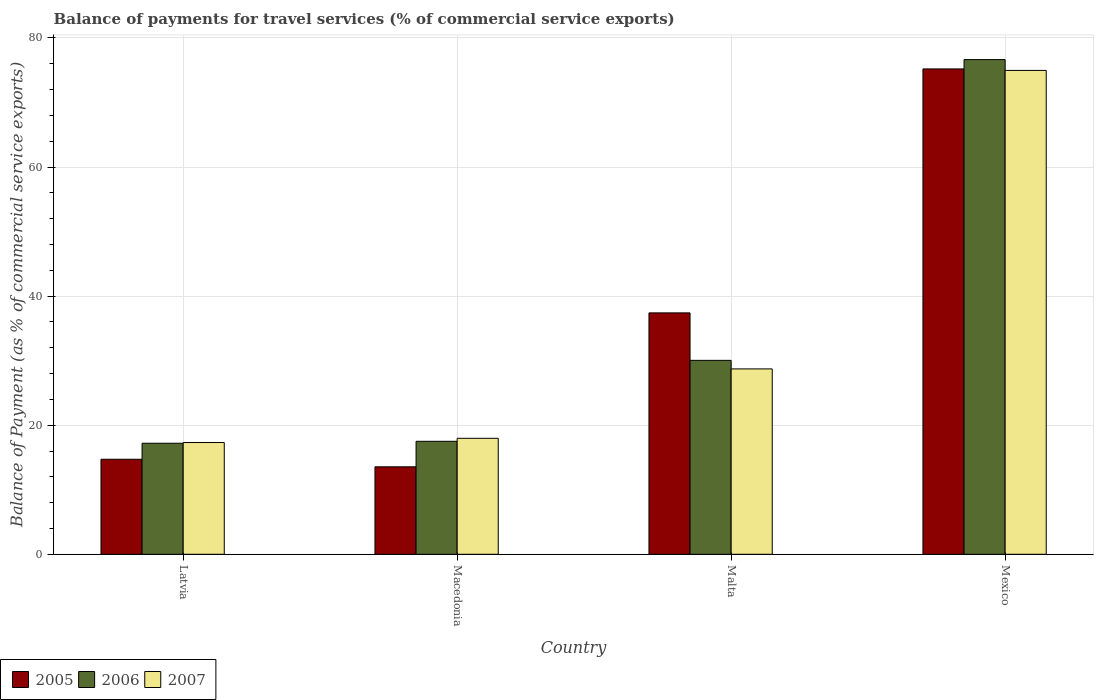Are the number of bars on each tick of the X-axis equal?
Make the answer very short. Yes. What is the label of the 1st group of bars from the left?
Your answer should be compact. Latvia. What is the balance of payments for travel services in 2006 in Malta?
Provide a short and direct response. 30.05. Across all countries, what is the maximum balance of payments for travel services in 2006?
Provide a succinct answer. 76.64. Across all countries, what is the minimum balance of payments for travel services in 2007?
Your answer should be compact. 17.32. In which country was the balance of payments for travel services in 2006 maximum?
Offer a very short reply. Mexico. In which country was the balance of payments for travel services in 2006 minimum?
Your answer should be compact. Latvia. What is the total balance of payments for travel services in 2005 in the graph?
Make the answer very short. 140.87. What is the difference between the balance of payments for travel services in 2005 in Latvia and that in Macedonia?
Your answer should be compact. 1.17. What is the difference between the balance of payments for travel services in 2007 in Malta and the balance of payments for travel services in 2005 in Macedonia?
Give a very brief answer. 15.17. What is the average balance of payments for travel services in 2007 per country?
Ensure brevity in your answer.  34.74. What is the difference between the balance of payments for travel services of/in 2007 and balance of payments for travel services of/in 2006 in Malta?
Offer a very short reply. -1.32. In how many countries, is the balance of payments for travel services in 2007 greater than 24 %?
Ensure brevity in your answer.  2. What is the ratio of the balance of payments for travel services in 2005 in Latvia to that in Mexico?
Offer a very short reply. 0.2. Is the difference between the balance of payments for travel services in 2007 in Macedonia and Mexico greater than the difference between the balance of payments for travel services in 2006 in Macedonia and Mexico?
Provide a short and direct response. Yes. What is the difference between the highest and the second highest balance of payments for travel services in 2006?
Give a very brief answer. -59.14. What is the difference between the highest and the lowest balance of payments for travel services in 2005?
Make the answer very short. 61.64. In how many countries, is the balance of payments for travel services in 2005 greater than the average balance of payments for travel services in 2005 taken over all countries?
Your response must be concise. 2. Is the sum of the balance of payments for travel services in 2007 in Malta and Mexico greater than the maximum balance of payments for travel services in 2006 across all countries?
Give a very brief answer. Yes. What does the 2nd bar from the left in Malta represents?
Your answer should be very brief. 2006. Is it the case that in every country, the sum of the balance of payments for travel services in 2006 and balance of payments for travel services in 2007 is greater than the balance of payments for travel services in 2005?
Your answer should be very brief. Yes. How many bars are there?
Your answer should be compact. 12. What is the difference between two consecutive major ticks on the Y-axis?
Your answer should be very brief. 20. Are the values on the major ticks of Y-axis written in scientific E-notation?
Provide a short and direct response. No. Does the graph contain any zero values?
Provide a succinct answer. No. Does the graph contain grids?
Give a very brief answer. Yes. Where does the legend appear in the graph?
Keep it short and to the point. Bottom left. What is the title of the graph?
Your answer should be compact. Balance of payments for travel services (% of commercial service exports). Does "1962" appear as one of the legend labels in the graph?
Make the answer very short. No. What is the label or title of the Y-axis?
Provide a short and direct response. Balance of Payment (as % of commercial service exports). What is the Balance of Payment (as % of commercial service exports) in 2005 in Latvia?
Your response must be concise. 14.72. What is the Balance of Payment (as % of commercial service exports) in 2006 in Latvia?
Your answer should be very brief. 17.2. What is the Balance of Payment (as % of commercial service exports) of 2007 in Latvia?
Keep it short and to the point. 17.32. What is the Balance of Payment (as % of commercial service exports) of 2005 in Macedonia?
Your answer should be very brief. 13.55. What is the Balance of Payment (as % of commercial service exports) in 2006 in Macedonia?
Ensure brevity in your answer.  17.5. What is the Balance of Payment (as % of commercial service exports) of 2007 in Macedonia?
Your answer should be compact. 17.97. What is the Balance of Payment (as % of commercial service exports) of 2005 in Malta?
Provide a short and direct response. 37.4. What is the Balance of Payment (as % of commercial service exports) of 2006 in Malta?
Provide a succinct answer. 30.05. What is the Balance of Payment (as % of commercial service exports) of 2007 in Malta?
Ensure brevity in your answer.  28.72. What is the Balance of Payment (as % of commercial service exports) in 2005 in Mexico?
Ensure brevity in your answer.  75.19. What is the Balance of Payment (as % of commercial service exports) of 2006 in Mexico?
Your answer should be compact. 76.64. What is the Balance of Payment (as % of commercial service exports) in 2007 in Mexico?
Make the answer very short. 74.97. Across all countries, what is the maximum Balance of Payment (as % of commercial service exports) of 2005?
Make the answer very short. 75.19. Across all countries, what is the maximum Balance of Payment (as % of commercial service exports) of 2006?
Your answer should be very brief. 76.64. Across all countries, what is the maximum Balance of Payment (as % of commercial service exports) in 2007?
Keep it short and to the point. 74.97. Across all countries, what is the minimum Balance of Payment (as % of commercial service exports) of 2005?
Your response must be concise. 13.55. Across all countries, what is the minimum Balance of Payment (as % of commercial service exports) in 2006?
Keep it short and to the point. 17.2. Across all countries, what is the minimum Balance of Payment (as % of commercial service exports) in 2007?
Provide a short and direct response. 17.32. What is the total Balance of Payment (as % of commercial service exports) in 2005 in the graph?
Keep it short and to the point. 140.87. What is the total Balance of Payment (as % of commercial service exports) of 2006 in the graph?
Ensure brevity in your answer.  141.39. What is the total Balance of Payment (as % of commercial service exports) in 2007 in the graph?
Offer a very short reply. 138.98. What is the difference between the Balance of Payment (as % of commercial service exports) in 2005 in Latvia and that in Macedonia?
Make the answer very short. 1.17. What is the difference between the Balance of Payment (as % of commercial service exports) in 2006 in Latvia and that in Macedonia?
Keep it short and to the point. -0.3. What is the difference between the Balance of Payment (as % of commercial service exports) in 2007 in Latvia and that in Macedonia?
Provide a succinct answer. -0.65. What is the difference between the Balance of Payment (as % of commercial service exports) in 2005 in Latvia and that in Malta?
Provide a succinct answer. -22.68. What is the difference between the Balance of Payment (as % of commercial service exports) in 2006 in Latvia and that in Malta?
Your answer should be compact. -12.84. What is the difference between the Balance of Payment (as % of commercial service exports) of 2007 in Latvia and that in Malta?
Provide a short and direct response. -11.4. What is the difference between the Balance of Payment (as % of commercial service exports) in 2005 in Latvia and that in Mexico?
Make the answer very short. -60.47. What is the difference between the Balance of Payment (as % of commercial service exports) in 2006 in Latvia and that in Mexico?
Your answer should be very brief. -59.44. What is the difference between the Balance of Payment (as % of commercial service exports) of 2007 in Latvia and that in Mexico?
Your answer should be very brief. -57.65. What is the difference between the Balance of Payment (as % of commercial service exports) in 2005 in Macedonia and that in Malta?
Ensure brevity in your answer.  -23.85. What is the difference between the Balance of Payment (as % of commercial service exports) of 2006 in Macedonia and that in Malta?
Provide a succinct answer. -12.54. What is the difference between the Balance of Payment (as % of commercial service exports) in 2007 in Macedonia and that in Malta?
Your answer should be very brief. -10.75. What is the difference between the Balance of Payment (as % of commercial service exports) of 2005 in Macedonia and that in Mexico?
Your answer should be very brief. -61.64. What is the difference between the Balance of Payment (as % of commercial service exports) in 2006 in Macedonia and that in Mexico?
Provide a succinct answer. -59.14. What is the difference between the Balance of Payment (as % of commercial service exports) of 2007 in Macedonia and that in Mexico?
Your response must be concise. -57. What is the difference between the Balance of Payment (as % of commercial service exports) of 2005 in Malta and that in Mexico?
Your response must be concise. -37.79. What is the difference between the Balance of Payment (as % of commercial service exports) of 2006 in Malta and that in Mexico?
Provide a succinct answer. -46.59. What is the difference between the Balance of Payment (as % of commercial service exports) in 2007 in Malta and that in Mexico?
Offer a terse response. -46.24. What is the difference between the Balance of Payment (as % of commercial service exports) of 2005 in Latvia and the Balance of Payment (as % of commercial service exports) of 2006 in Macedonia?
Ensure brevity in your answer.  -2.78. What is the difference between the Balance of Payment (as % of commercial service exports) in 2005 in Latvia and the Balance of Payment (as % of commercial service exports) in 2007 in Macedonia?
Keep it short and to the point. -3.25. What is the difference between the Balance of Payment (as % of commercial service exports) of 2006 in Latvia and the Balance of Payment (as % of commercial service exports) of 2007 in Macedonia?
Your answer should be compact. -0.77. What is the difference between the Balance of Payment (as % of commercial service exports) of 2005 in Latvia and the Balance of Payment (as % of commercial service exports) of 2006 in Malta?
Your answer should be very brief. -15.32. What is the difference between the Balance of Payment (as % of commercial service exports) in 2005 in Latvia and the Balance of Payment (as % of commercial service exports) in 2007 in Malta?
Provide a succinct answer. -14. What is the difference between the Balance of Payment (as % of commercial service exports) of 2006 in Latvia and the Balance of Payment (as % of commercial service exports) of 2007 in Malta?
Provide a short and direct response. -11.52. What is the difference between the Balance of Payment (as % of commercial service exports) in 2005 in Latvia and the Balance of Payment (as % of commercial service exports) in 2006 in Mexico?
Offer a very short reply. -61.92. What is the difference between the Balance of Payment (as % of commercial service exports) in 2005 in Latvia and the Balance of Payment (as % of commercial service exports) in 2007 in Mexico?
Keep it short and to the point. -60.24. What is the difference between the Balance of Payment (as % of commercial service exports) of 2006 in Latvia and the Balance of Payment (as % of commercial service exports) of 2007 in Mexico?
Provide a short and direct response. -57.76. What is the difference between the Balance of Payment (as % of commercial service exports) in 2005 in Macedonia and the Balance of Payment (as % of commercial service exports) in 2006 in Malta?
Give a very brief answer. -16.49. What is the difference between the Balance of Payment (as % of commercial service exports) of 2005 in Macedonia and the Balance of Payment (as % of commercial service exports) of 2007 in Malta?
Your answer should be compact. -15.17. What is the difference between the Balance of Payment (as % of commercial service exports) of 2006 in Macedonia and the Balance of Payment (as % of commercial service exports) of 2007 in Malta?
Make the answer very short. -11.22. What is the difference between the Balance of Payment (as % of commercial service exports) in 2005 in Macedonia and the Balance of Payment (as % of commercial service exports) in 2006 in Mexico?
Ensure brevity in your answer.  -63.09. What is the difference between the Balance of Payment (as % of commercial service exports) in 2005 in Macedonia and the Balance of Payment (as % of commercial service exports) in 2007 in Mexico?
Your answer should be compact. -61.41. What is the difference between the Balance of Payment (as % of commercial service exports) in 2006 in Macedonia and the Balance of Payment (as % of commercial service exports) in 2007 in Mexico?
Keep it short and to the point. -57.46. What is the difference between the Balance of Payment (as % of commercial service exports) in 2005 in Malta and the Balance of Payment (as % of commercial service exports) in 2006 in Mexico?
Give a very brief answer. -39.24. What is the difference between the Balance of Payment (as % of commercial service exports) in 2005 in Malta and the Balance of Payment (as % of commercial service exports) in 2007 in Mexico?
Offer a very short reply. -37.57. What is the difference between the Balance of Payment (as % of commercial service exports) in 2006 in Malta and the Balance of Payment (as % of commercial service exports) in 2007 in Mexico?
Your answer should be very brief. -44.92. What is the average Balance of Payment (as % of commercial service exports) of 2005 per country?
Keep it short and to the point. 35.22. What is the average Balance of Payment (as % of commercial service exports) in 2006 per country?
Offer a terse response. 35.35. What is the average Balance of Payment (as % of commercial service exports) of 2007 per country?
Offer a very short reply. 34.74. What is the difference between the Balance of Payment (as % of commercial service exports) of 2005 and Balance of Payment (as % of commercial service exports) of 2006 in Latvia?
Ensure brevity in your answer.  -2.48. What is the difference between the Balance of Payment (as % of commercial service exports) of 2005 and Balance of Payment (as % of commercial service exports) of 2007 in Latvia?
Give a very brief answer. -2.59. What is the difference between the Balance of Payment (as % of commercial service exports) of 2006 and Balance of Payment (as % of commercial service exports) of 2007 in Latvia?
Your response must be concise. -0.11. What is the difference between the Balance of Payment (as % of commercial service exports) in 2005 and Balance of Payment (as % of commercial service exports) in 2006 in Macedonia?
Keep it short and to the point. -3.95. What is the difference between the Balance of Payment (as % of commercial service exports) in 2005 and Balance of Payment (as % of commercial service exports) in 2007 in Macedonia?
Make the answer very short. -4.42. What is the difference between the Balance of Payment (as % of commercial service exports) of 2006 and Balance of Payment (as % of commercial service exports) of 2007 in Macedonia?
Offer a very short reply. -0.47. What is the difference between the Balance of Payment (as % of commercial service exports) of 2005 and Balance of Payment (as % of commercial service exports) of 2006 in Malta?
Your answer should be compact. 7.35. What is the difference between the Balance of Payment (as % of commercial service exports) of 2005 and Balance of Payment (as % of commercial service exports) of 2007 in Malta?
Provide a short and direct response. 8.68. What is the difference between the Balance of Payment (as % of commercial service exports) of 2006 and Balance of Payment (as % of commercial service exports) of 2007 in Malta?
Your answer should be very brief. 1.32. What is the difference between the Balance of Payment (as % of commercial service exports) in 2005 and Balance of Payment (as % of commercial service exports) in 2006 in Mexico?
Keep it short and to the point. -1.45. What is the difference between the Balance of Payment (as % of commercial service exports) in 2005 and Balance of Payment (as % of commercial service exports) in 2007 in Mexico?
Make the answer very short. 0.23. What is the difference between the Balance of Payment (as % of commercial service exports) in 2006 and Balance of Payment (as % of commercial service exports) in 2007 in Mexico?
Ensure brevity in your answer.  1.67. What is the ratio of the Balance of Payment (as % of commercial service exports) in 2005 in Latvia to that in Macedonia?
Offer a very short reply. 1.09. What is the ratio of the Balance of Payment (as % of commercial service exports) of 2006 in Latvia to that in Macedonia?
Provide a short and direct response. 0.98. What is the ratio of the Balance of Payment (as % of commercial service exports) in 2007 in Latvia to that in Macedonia?
Keep it short and to the point. 0.96. What is the ratio of the Balance of Payment (as % of commercial service exports) of 2005 in Latvia to that in Malta?
Provide a succinct answer. 0.39. What is the ratio of the Balance of Payment (as % of commercial service exports) in 2006 in Latvia to that in Malta?
Ensure brevity in your answer.  0.57. What is the ratio of the Balance of Payment (as % of commercial service exports) of 2007 in Latvia to that in Malta?
Your answer should be very brief. 0.6. What is the ratio of the Balance of Payment (as % of commercial service exports) in 2005 in Latvia to that in Mexico?
Your answer should be very brief. 0.2. What is the ratio of the Balance of Payment (as % of commercial service exports) of 2006 in Latvia to that in Mexico?
Provide a short and direct response. 0.22. What is the ratio of the Balance of Payment (as % of commercial service exports) in 2007 in Latvia to that in Mexico?
Ensure brevity in your answer.  0.23. What is the ratio of the Balance of Payment (as % of commercial service exports) in 2005 in Macedonia to that in Malta?
Provide a succinct answer. 0.36. What is the ratio of the Balance of Payment (as % of commercial service exports) in 2006 in Macedonia to that in Malta?
Your response must be concise. 0.58. What is the ratio of the Balance of Payment (as % of commercial service exports) in 2007 in Macedonia to that in Malta?
Provide a succinct answer. 0.63. What is the ratio of the Balance of Payment (as % of commercial service exports) of 2005 in Macedonia to that in Mexico?
Offer a terse response. 0.18. What is the ratio of the Balance of Payment (as % of commercial service exports) in 2006 in Macedonia to that in Mexico?
Offer a terse response. 0.23. What is the ratio of the Balance of Payment (as % of commercial service exports) in 2007 in Macedonia to that in Mexico?
Give a very brief answer. 0.24. What is the ratio of the Balance of Payment (as % of commercial service exports) in 2005 in Malta to that in Mexico?
Offer a terse response. 0.5. What is the ratio of the Balance of Payment (as % of commercial service exports) of 2006 in Malta to that in Mexico?
Your answer should be compact. 0.39. What is the ratio of the Balance of Payment (as % of commercial service exports) of 2007 in Malta to that in Mexico?
Your response must be concise. 0.38. What is the difference between the highest and the second highest Balance of Payment (as % of commercial service exports) of 2005?
Offer a very short reply. 37.79. What is the difference between the highest and the second highest Balance of Payment (as % of commercial service exports) in 2006?
Make the answer very short. 46.59. What is the difference between the highest and the second highest Balance of Payment (as % of commercial service exports) of 2007?
Keep it short and to the point. 46.24. What is the difference between the highest and the lowest Balance of Payment (as % of commercial service exports) in 2005?
Provide a succinct answer. 61.64. What is the difference between the highest and the lowest Balance of Payment (as % of commercial service exports) of 2006?
Ensure brevity in your answer.  59.44. What is the difference between the highest and the lowest Balance of Payment (as % of commercial service exports) in 2007?
Keep it short and to the point. 57.65. 